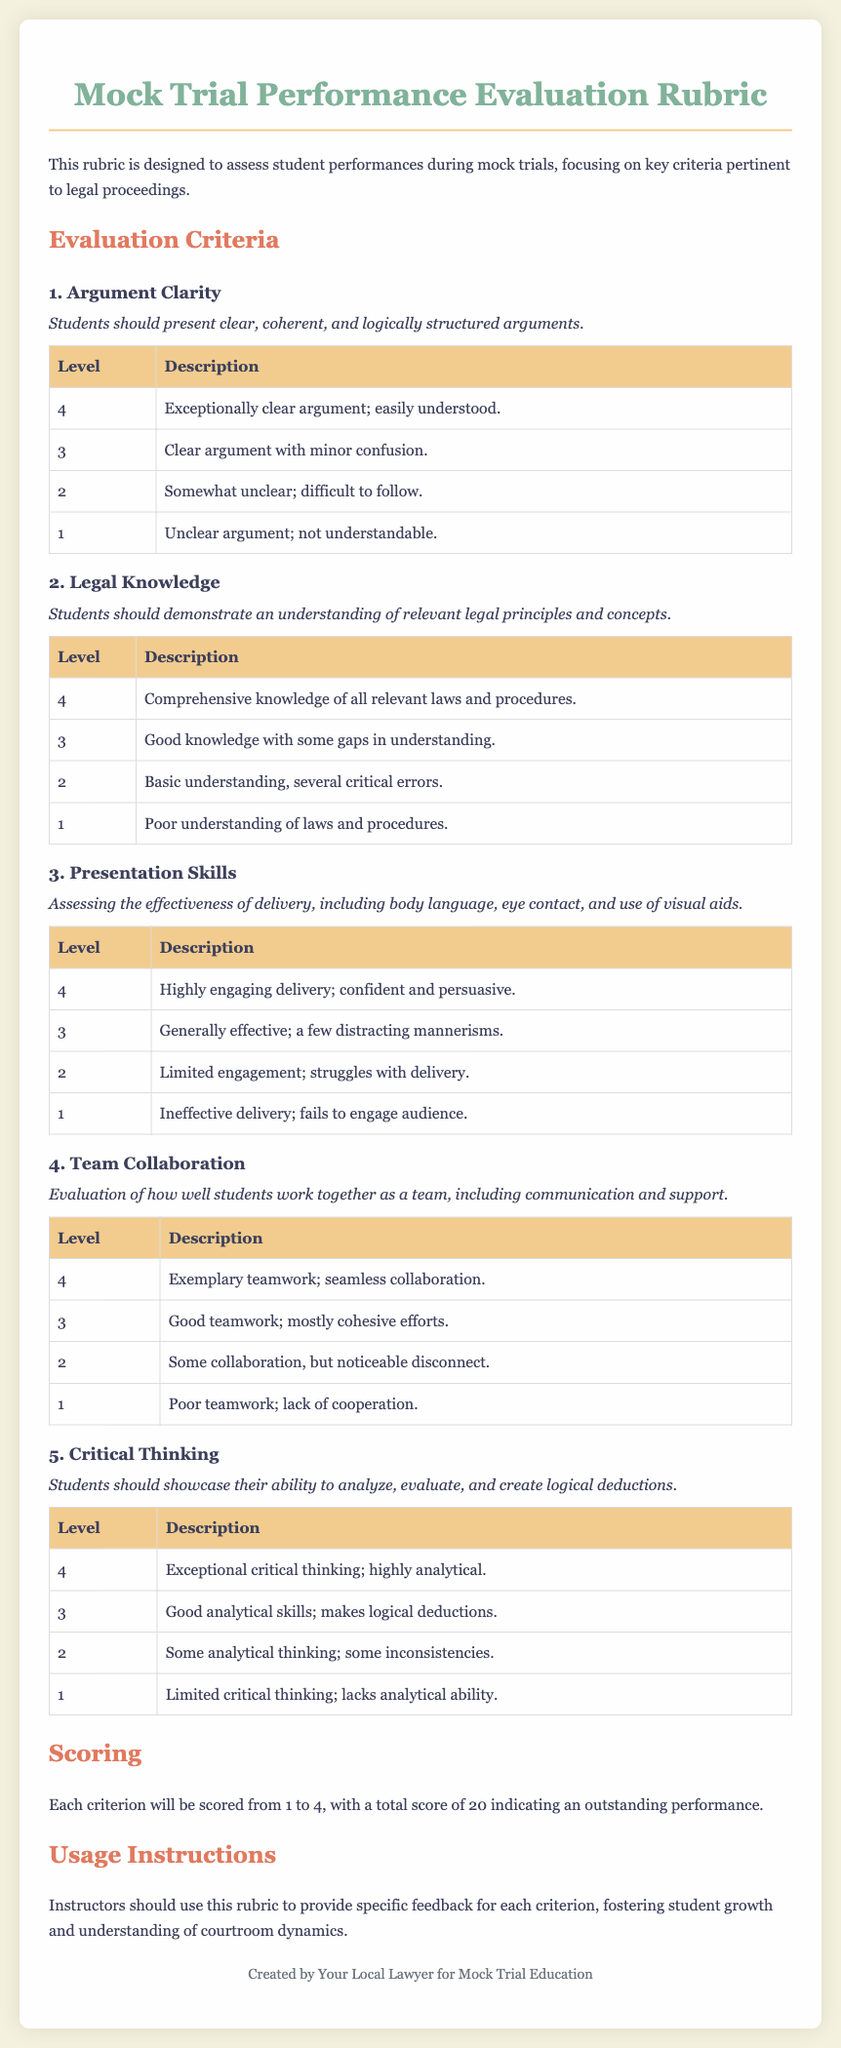What is the title of the document? The title is found in the heading at the top of the document.
Answer: Mock Trial Performance Evaluation Rubric What is the maximum score a student can achieve? The maximum score is stated in the scoring section of the document.
Answer: 20 How many criteria are evaluated in the rubric? The number of criteria can be counted in the evaluation criteria section.
Answer: 5 What is the highest level for Argument Clarity? The highest level is detailed in the Argument Clarity table.
Answer: 4 What is the description of level 2 for Legal Knowledge? The description is in the Legal Knowledge table.
Answer: Basic understanding, several critical errors What does the criteria for Team Collaboration evaluate? This is explained in the description under the Team Collaboration section.
Answer: How well students work together as a team, including communication and support Which level indicates poor teamwork? This can be found in the Team Collaboration table.
Answer: 1 What should instructors use the rubric for? The purpose is stated in the usage instructions section.
Answer: Provide specific feedback for each criterion What is the lowest score indicating effective delivery in Presentation Skills? The lowest score information is in the Presentation Skills table.
Answer: 1 